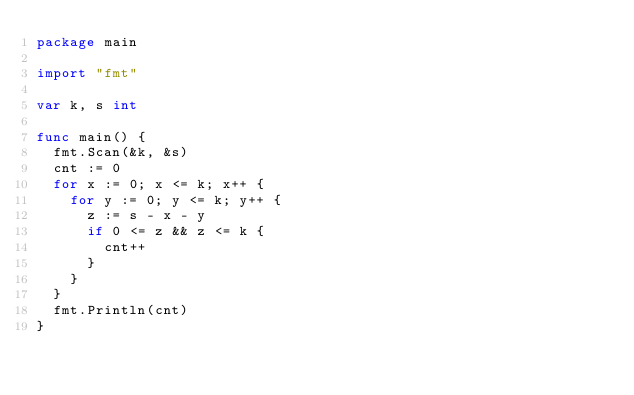Convert code to text. <code><loc_0><loc_0><loc_500><loc_500><_Go_>package main

import "fmt"

var k, s int

func main() {
	fmt.Scan(&k, &s)
	cnt := 0
	for x := 0; x <= k; x++ {
		for y := 0; y <= k; y++ {
			z := s - x - y
			if 0 <= z && z <= k {
				cnt++
			}
		}
	}
	fmt.Println(cnt)
}
</code> 